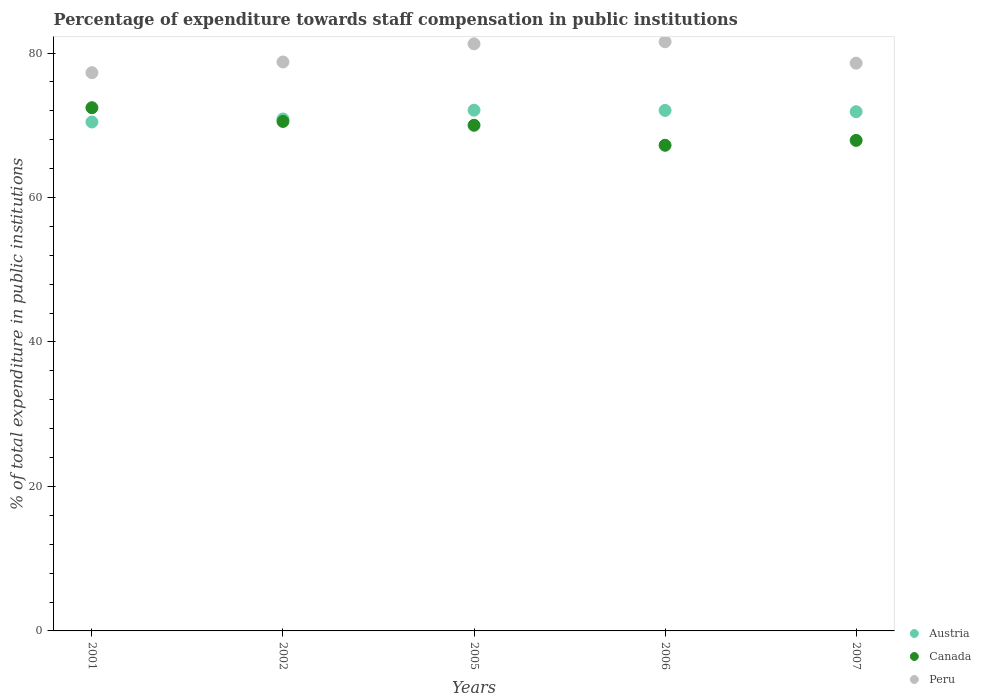What is the percentage of expenditure towards staff compensation in Peru in 2001?
Ensure brevity in your answer.  77.28. Across all years, what is the maximum percentage of expenditure towards staff compensation in Austria?
Make the answer very short. 72.09. Across all years, what is the minimum percentage of expenditure towards staff compensation in Austria?
Keep it short and to the point. 70.45. In which year was the percentage of expenditure towards staff compensation in Canada minimum?
Keep it short and to the point. 2006. What is the total percentage of expenditure towards staff compensation in Austria in the graph?
Your response must be concise. 357.34. What is the difference between the percentage of expenditure towards staff compensation in Canada in 2002 and that in 2006?
Ensure brevity in your answer.  3.3. What is the difference between the percentage of expenditure towards staff compensation in Canada in 2002 and the percentage of expenditure towards staff compensation in Peru in 2007?
Ensure brevity in your answer.  -8.07. What is the average percentage of expenditure towards staff compensation in Peru per year?
Ensure brevity in your answer.  79.49. In the year 2005, what is the difference between the percentage of expenditure towards staff compensation in Austria and percentage of expenditure towards staff compensation in Canada?
Make the answer very short. 2.09. What is the ratio of the percentage of expenditure towards staff compensation in Peru in 2001 to that in 2007?
Your response must be concise. 0.98. Is the percentage of expenditure towards staff compensation in Peru in 2001 less than that in 2002?
Ensure brevity in your answer.  Yes. What is the difference between the highest and the second highest percentage of expenditure towards staff compensation in Austria?
Your response must be concise. 0.03. What is the difference between the highest and the lowest percentage of expenditure towards staff compensation in Canada?
Ensure brevity in your answer.  5.2. Is the sum of the percentage of expenditure towards staff compensation in Canada in 2002 and 2005 greater than the maximum percentage of expenditure towards staff compensation in Austria across all years?
Your answer should be very brief. Yes. Does the percentage of expenditure towards staff compensation in Austria monotonically increase over the years?
Your response must be concise. No. Is the percentage of expenditure towards staff compensation in Austria strictly greater than the percentage of expenditure towards staff compensation in Canada over the years?
Provide a short and direct response. No. Is the percentage of expenditure towards staff compensation in Peru strictly less than the percentage of expenditure towards staff compensation in Canada over the years?
Offer a terse response. No. How many dotlines are there?
Keep it short and to the point. 3. Does the graph contain any zero values?
Provide a short and direct response. No. Does the graph contain grids?
Make the answer very short. No. How many legend labels are there?
Make the answer very short. 3. What is the title of the graph?
Your response must be concise. Percentage of expenditure towards staff compensation in public institutions. What is the label or title of the X-axis?
Offer a terse response. Years. What is the label or title of the Y-axis?
Ensure brevity in your answer.  % of total expenditure in public institutions. What is the % of total expenditure in public institutions in Austria in 2001?
Provide a succinct answer. 70.45. What is the % of total expenditure in public institutions in Canada in 2001?
Your response must be concise. 72.43. What is the % of total expenditure in public institutions of Peru in 2001?
Your response must be concise. 77.28. What is the % of total expenditure in public institutions of Austria in 2002?
Provide a short and direct response. 70.87. What is the % of total expenditure in public institutions in Canada in 2002?
Make the answer very short. 70.53. What is the % of total expenditure in public institutions of Peru in 2002?
Give a very brief answer. 78.76. What is the % of total expenditure in public institutions of Austria in 2005?
Offer a very short reply. 72.09. What is the % of total expenditure in public institutions of Canada in 2005?
Keep it short and to the point. 70. What is the % of total expenditure in public institutions of Peru in 2005?
Provide a succinct answer. 81.27. What is the % of total expenditure in public institutions of Austria in 2006?
Make the answer very short. 72.06. What is the % of total expenditure in public institutions in Canada in 2006?
Offer a terse response. 67.23. What is the % of total expenditure in public institutions in Peru in 2006?
Make the answer very short. 81.56. What is the % of total expenditure in public institutions of Austria in 2007?
Keep it short and to the point. 71.88. What is the % of total expenditure in public institutions of Canada in 2007?
Keep it short and to the point. 67.91. What is the % of total expenditure in public institutions of Peru in 2007?
Provide a short and direct response. 78.6. Across all years, what is the maximum % of total expenditure in public institutions of Austria?
Provide a short and direct response. 72.09. Across all years, what is the maximum % of total expenditure in public institutions in Canada?
Your answer should be very brief. 72.43. Across all years, what is the maximum % of total expenditure in public institutions of Peru?
Offer a terse response. 81.56. Across all years, what is the minimum % of total expenditure in public institutions in Austria?
Give a very brief answer. 70.45. Across all years, what is the minimum % of total expenditure in public institutions in Canada?
Your response must be concise. 67.23. Across all years, what is the minimum % of total expenditure in public institutions of Peru?
Offer a very short reply. 77.28. What is the total % of total expenditure in public institutions of Austria in the graph?
Provide a succinct answer. 357.34. What is the total % of total expenditure in public institutions of Canada in the graph?
Ensure brevity in your answer.  348.1. What is the total % of total expenditure in public institutions in Peru in the graph?
Provide a short and direct response. 397.46. What is the difference between the % of total expenditure in public institutions in Austria in 2001 and that in 2002?
Your answer should be compact. -0.42. What is the difference between the % of total expenditure in public institutions in Canada in 2001 and that in 2002?
Your answer should be very brief. 1.9. What is the difference between the % of total expenditure in public institutions in Peru in 2001 and that in 2002?
Ensure brevity in your answer.  -1.49. What is the difference between the % of total expenditure in public institutions in Austria in 2001 and that in 2005?
Offer a very short reply. -1.63. What is the difference between the % of total expenditure in public institutions of Canada in 2001 and that in 2005?
Your answer should be compact. 2.43. What is the difference between the % of total expenditure in public institutions in Peru in 2001 and that in 2005?
Your answer should be very brief. -4. What is the difference between the % of total expenditure in public institutions in Austria in 2001 and that in 2006?
Your answer should be compact. -1.6. What is the difference between the % of total expenditure in public institutions of Canada in 2001 and that in 2006?
Give a very brief answer. 5.2. What is the difference between the % of total expenditure in public institutions of Peru in 2001 and that in 2006?
Your answer should be compact. -4.28. What is the difference between the % of total expenditure in public institutions of Austria in 2001 and that in 2007?
Your answer should be very brief. -1.43. What is the difference between the % of total expenditure in public institutions in Canada in 2001 and that in 2007?
Your response must be concise. 4.53. What is the difference between the % of total expenditure in public institutions of Peru in 2001 and that in 2007?
Your response must be concise. -1.32. What is the difference between the % of total expenditure in public institutions of Austria in 2002 and that in 2005?
Keep it short and to the point. -1.22. What is the difference between the % of total expenditure in public institutions of Canada in 2002 and that in 2005?
Make the answer very short. 0.53. What is the difference between the % of total expenditure in public institutions in Peru in 2002 and that in 2005?
Make the answer very short. -2.51. What is the difference between the % of total expenditure in public institutions in Austria in 2002 and that in 2006?
Your response must be concise. -1.19. What is the difference between the % of total expenditure in public institutions in Canada in 2002 and that in 2006?
Keep it short and to the point. 3.3. What is the difference between the % of total expenditure in public institutions in Peru in 2002 and that in 2006?
Provide a succinct answer. -2.8. What is the difference between the % of total expenditure in public institutions in Austria in 2002 and that in 2007?
Your response must be concise. -1.01. What is the difference between the % of total expenditure in public institutions in Canada in 2002 and that in 2007?
Your answer should be compact. 2.62. What is the difference between the % of total expenditure in public institutions in Peru in 2002 and that in 2007?
Your response must be concise. 0.17. What is the difference between the % of total expenditure in public institutions of Austria in 2005 and that in 2006?
Provide a short and direct response. 0.03. What is the difference between the % of total expenditure in public institutions in Canada in 2005 and that in 2006?
Offer a terse response. 2.77. What is the difference between the % of total expenditure in public institutions in Peru in 2005 and that in 2006?
Your answer should be compact. -0.29. What is the difference between the % of total expenditure in public institutions of Austria in 2005 and that in 2007?
Provide a succinct answer. 0.21. What is the difference between the % of total expenditure in public institutions of Canada in 2005 and that in 2007?
Your answer should be very brief. 2.09. What is the difference between the % of total expenditure in public institutions of Peru in 2005 and that in 2007?
Keep it short and to the point. 2.68. What is the difference between the % of total expenditure in public institutions in Austria in 2006 and that in 2007?
Give a very brief answer. 0.18. What is the difference between the % of total expenditure in public institutions in Canada in 2006 and that in 2007?
Keep it short and to the point. -0.68. What is the difference between the % of total expenditure in public institutions in Peru in 2006 and that in 2007?
Keep it short and to the point. 2.97. What is the difference between the % of total expenditure in public institutions of Austria in 2001 and the % of total expenditure in public institutions of Canada in 2002?
Offer a terse response. -0.08. What is the difference between the % of total expenditure in public institutions of Austria in 2001 and the % of total expenditure in public institutions of Peru in 2002?
Offer a very short reply. -8.31. What is the difference between the % of total expenditure in public institutions in Canada in 2001 and the % of total expenditure in public institutions in Peru in 2002?
Your answer should be very brief. -6.33. What is the difference between the % of total expenditure in public institutions in Austria in 2001 and the % of total expenditure in public institutions in Canada in 2005?
Your answer should be compact. 0.45. What is the difference between the % of total expenditure in public institutions in Austria in 2001 and the % of total expenditure in public institutions in Peru in 2005?
Your response must be concise. -10.82. What is the difference between the % of total expenditure in public institutions in Canada in 2001 and the % of total expenditure in public institutions in Peru in 2005?
Provide a succinct answer. -8.84. What is the difference between the % of total expenditure in public institutions of Austria in 2001 and the % of total expenditure in public institutions of Canada in 2006?
Your answer should be very brief. 3.22. What is the difference between the % of total expenditure in public institutions of Austria in 2001 and the % of total expenditure in public institutions of Peru in 2006?
Your answer should be compact. -11.11. What is the difference between the % of total expenditure in public institutions in Canada in 2001 and the % of total expenditure in public institutions in Peru in 2006?
Make the answer very short. -9.13. What is the difference between the % of total expenditure in public institutions of Austria in 2001 and the % of total expenditure in public institutions of Canada in 2007?
Provide a short and direct response. 2.55. What is the difference between the % of total expenditure in public institutions of Austria in 2001 and the % of total expenditure in public institutions of Peru in 2007?
Keep it short and to the point. -8.14. What is the difference between the % of total expenditure in public institutions of Canada in 2001 and the % of total expenditure in public institutions of Peru in 2007?
Give a very brief answer. -6.16. What is the difference between the % of total expenditure in public institutions of Austria in 2002 and the % of total expenditure in public institutions of Canada in 2005?
Your answer should be very brief. 0.87. What is the difference between the % of total expenditure in public institutions of Austria in 2002 and the % of total expenditure in public institutions of Peru in 2005?
Keep it short and to the point. -10.4. What is the difference between the % of total expenditure in public institutions in Canada in 2002 and the % of total expenditure in public institutions in Peru in 2005?
Provide a short and direct response. -10.74. What is the difference between the % of total expenditure in public institutions of Austria in 2002 and the % of total expenditure in public institutions of Canada in 2006?
Provide a succinct answer. 3.64. What is the difference between the % of total expenditure in public institutions in Austria in 2002 and the % of total expenditure in public institutions in Peru in 2006?
Ensure brevity in your answer.  -10.69. What is the difference between the % of total expenditure in public institutions in Canada in 2002 and the % of total expenditure in public institutions in Peru in 2006?
Offer a very short reply. -11.03. What is the difference between the % of total expenditure in public institutions of Austria in 2002 and the % of total expenditure in public institutions of Canada in 2007?
Offer a terse response. 2.96. What is the difference between the % of total expenditure in public institutions in Austria in 2002 and the % of total expenditure in public institutions in Peru in 2007?
Provide a short and direct response. -7.73. What is the difference between the % of total expenditure in public institutions in Canada in 2002 and the % of total expenditure in public institutions in Peru in 2007?
Make the answer very short. -8.07. What is the difference between the % of total expenditure in public institutions of Austria in 2005 and the % of total expenditure in public institutions of Canada in 2006?
Offer a terse response. 4.86. What is the difference between the % of total expenditure in public institutions of Austria in 2005 and the % of total expenditure in public institutions of Peru in 2006?
Your answer should be compact. -9.47. What is the difference between the % of total expenditure in public institutions of Canada in 2005 and the % of total expenditure in public institutions of Peru in 2006?
Your answer should be compact. -11.56. What is the difference between the % of total expenditure in public institutions in Austria in 2005 and the % of total expenditure in public institutions in Canada in 2007?
Ensure brevity in your answer.  4.18. What is the difference between the % of total expenditure in public institutions of Austria in 2005 and the % of total expenditure in public institutions of Peru in 2007?
Offer a very short reply. -6.51. What is the difference between the % of total expenditure in public institutions of Canada in 2005 and the % of total expenditure in public institutions of Peru in 2007?
Offer a terse response. -8.6. What is the difference between the % of total expenditure in public institutions in Austria in 2006 and the % of total expenditure in public institutions in Canada in 2007?
Offer a very short reply. 4.15. What is the difference between the % of total expenditure in public institutions in Austria in 2006 and the % of total expenditure in public institutions in Peru in 2007?
Give a very brief answer. -6.54. What is the difference between the % of total expenditure in public institutions in Canada in 2006 and the % of total expenditure in public institutions in Peru in 2007?
Your answer should be very brief. -11.37. What is the average % of total expenditure in public institutions in Austria per year?
Your answer should be compact. 71.47. What is the average % of total expenditure in public institutions of Canada per year?
Your answer should be very brief. 69.62. What is the average % of total expenditure in public institutions in Peru per year?
Make the answer very short. 79.49. In the year 2001, what is the difference between the % of total expenditure in public institutions in Austria and % of total expenditure in public institutions in Canada?
Ensure brevity in your answer.  -1.98. In the year 2001, what is the difference between the % of total expenditure in public institutions in Austria and % of total expenditure in public institutions in Peru?
Offer a very short reply. -6.82. In the year 2001, what is the difference between the % of total expenditure in public institutions in Canada and % of total expenditure in public institutions in Peru?
Offer a very short reply. -4.84. In the year 2002, what is the difference between the % of total expenditure in public institutions in Austria and % of total expenditure in public institutions in Canada?
Make the answer very short. 0.34. In the year 2002, what is the difference between the % of total expenditure in public institutions in Austria and % of total expenditure in public institutions in Peru?
Your response must be concise. -7.89. In the year 2002, what is the difference between the % of total expenditure in public institutions of Canada and % of total expenditure in public institutions of Peru?
Keep it short and to the point. -8.23. In the year 2005, what is the difference between the % of total expenditure in public institutions in Austria and % of total expenditure in public institutions in Canada?
Offer a terse response. 2.09. In the year 2005, what is the difference between the % of total expenditure in public institutions of Austria and % of total expenditure in public institutions of Peru?
Offer a terse response. -9.19. In the year 2005, what is the difference between the % of total expenditure in public institutions in Canada and % of total expenditure in public institutions in Peru?
Your answer should be compact. -11.27. In the year 2006, what is the difference between the % of total expenditure in public institutions of Austria and % of total expenditure in public institutions of Canada?
Offer a very short reply. 4.83. In the year 2006, what is the difference between the % of total expenditure in public institutions of Austria and % of total expenditure in public institutions of Peru?
Provide a short and direct response. -9.5. In the year 2006, what is the difference between the % of total expenditure in public institutions of Canada and % of total expenditure in public institutions of Peru?
Your answer should be very brief. -14.33. In the year 2007, what is the difference between the % of total expenditure in public institutions of Austria and % of total expenditure in public institutions of Canada?
Your answer should be very brief. 3.97. In the year 2007, what is the difference between the % of total expenditure in public institutions in Austria and % of total expenditure in public institutions in Peru?
Ensure brevity in your answer.  -6.72. In the year 2007, what is the difference between the % of total expenditure in public institutions in Canada and % of total expenditure in public institutions in Peru?
Provide a short and direct response. -10.69. What is the ratio of the % of total expenditure in public institutions of Austria in 2001 to that in 2002?
Provide a short and direct response. 0.99. What is the ratio of the % of total expenditure in public institutions in Peru in 2001 to that in 2002?
Your answer should be very brief. 0.98. What is the ratio of the % of total expenditure in public institutions of Austria in 2001 to that in 2005?
Give a very brief answer. 0.98. What is the ratio of the % of total expenditure in public institutions in Canada in 2001 to that in 2005?
Your response must be concise. 1.03. What is the ratio of the % of total expenditure in public institutions of Peru in 2001 to that in 2005?
Provide a succinct answer. 0.95. What is the ratio of the % of total expenditure in public institutions of Austria in 2001 to that in 2006?
Your answer should be very brief. 0.98. What is the ratio of the % of total expenditure in public institutions in Canada in 2001 to that in 2006?
Give a very brief answer. 1.08. What is the ratio of the % of total expenditure in public institutions of Peru in 2001 to that in 2006?
Give a very brief answer. 0.95. What is the ratio of the % of total expenditure in public institutions of Austria in 2001 to that in 2007?
Your answer should be very brief. 0.98. What is the ratio of the % of total expenditure in public institutions in Canada in 2001 to that in 2007?
Make the answer very short. 1.07. What is the ratio of the % of total expenditure in public institutions of Peru in 2001 to that in 2007?
Your response must be concise. 0.98. What is the ratio of the % of total expenditure in public institutions of Austria in 2002 to that in 2005?
Offer a very short reply. 0.98. What is the ratio of the % of total expenditure in public institutions in Canada in 2002 to that in 2005?
Your response must be concise. 1.01. What is the ratio of the % of total expenditure in public institutions of Peru in 2002 to that in 2005?
Provide a succinct answer. 0.97. What is the ratio of the % of total expenditure in public institutions in Austria in 2002 to that in 2006?
Make the answer very short. 0.98. What is the ratio of the % of total expenditure in public institutions of Canada in 2002 to that in 2006?
Give a very brief answer. 1.05. What is the ratio of the % of total expenditure in public institutions of Peru in 2002 to that in 2006?
Offer a very short reply. 0.97. What is the ratio of the % of total expenditure in public institutions of Canada in 2002 to that in 2007?
Ensure brevity in your answer.  1.04. What is the ratio of the % of total expenditure in public institutions in Peru in 2002 to that in 2007?
Provide a succinct answer. 1. What is the ratio of the % of total expenditure in public institutions of Canada in 2005 to that in 2006?
Provide a succinct answer. 1.04. What is the ratio of the % of total expenditure in public institutions of Austria in 2005 to that in 2007?
Your answer should be very brief. 1. What is the ratio of the % of total expenditure in public institutions in Canada in 2005 to that in 2007?
Offer a terse response. 1.03. What is the ratio of the % of total expenditure in public institutions of Peru in 2005 to that in 2007?
Provide a short and direct response. 1.03. What is the ratio of the % of total expenditure in public institutions in Austria in 2006 to that in 2007?
Your answer should be compact. 1. What is the ratio of the % of total expenditure in public institutions in Peru in 2006 to that in 2007?
Your answer should be very brief. 1.04. What is the difference between the highest and the second highest % of total expenditure in public institutions in Austria?
Keep it short and to the point. 0.03. What is the difference between the highest and the second highest % of total expenditure in public institutions of Canada?
Ensure brevity in your answer.  1.9. What is the difference between the highest and the second highest % of total expenditure in public institutions in Peru?
Make the answer very short. 0.29. What is the difference between the highest and the lowest % of total expenditure in public institutions of Austria?
Keep it short and to the point. 1.63. What is the difference between the highest and the lowest % of total expenditure in public institutions of Canada?
Your response must be concise. 5.2. What is the difference between the highest and the lowest % of total expenditure in public institutions in Peru?
Ensure brevity in your answer.  4.28. 